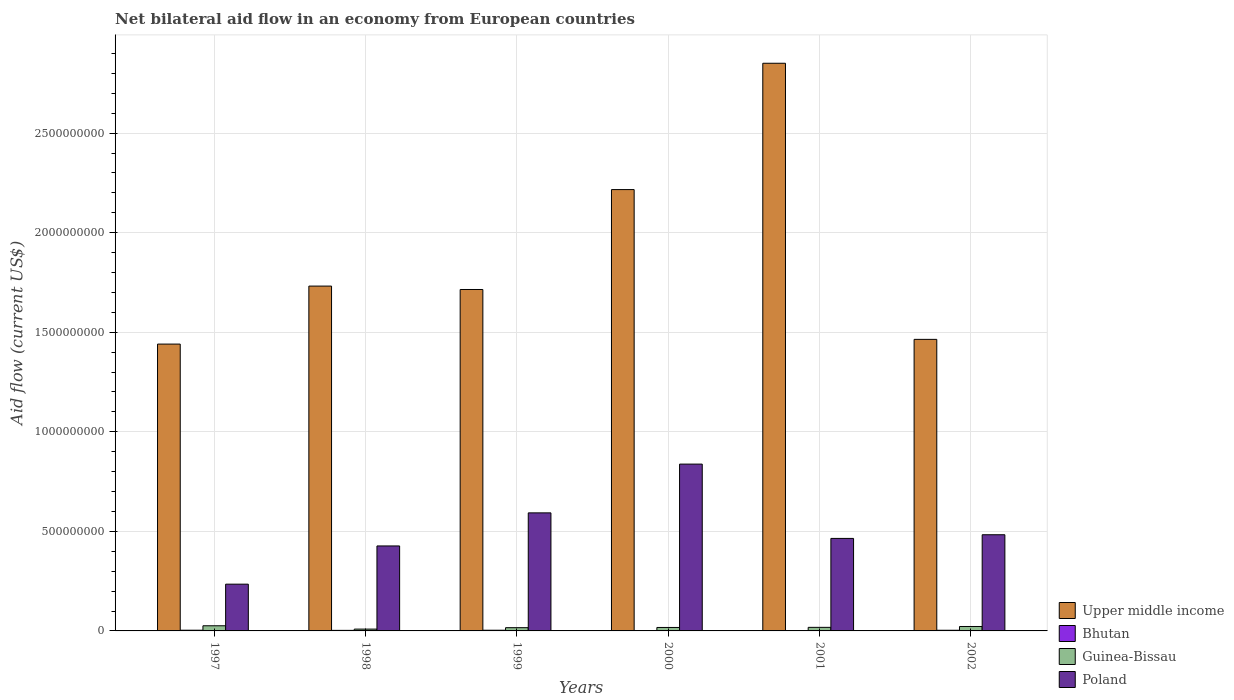How many different coloured bars are there?
Give a very brief answer. 4. How many groups of bars are there?
Offer a terse response. 6. Are the number of bars per tick equal to the number of legend labels?
Provide a succinct answer. Yes. How many bars are there on the 5th tick from the left?
Make the answer very short. 4. How many bars are there on the 1st tick from the right?
Make the answer very short. 4. What is the label of the 5th group of bars from the left?
Provide a succinct answer. 2001. In how many cases, is the number of bars for a given year not equal to the number of legend labels?
Offer a terse response. 0. What is the net bilateral aid flow in Bhutan in 1997?
Provide a succinct answer. 3.55e+06. Across all years, what is the maximum net bilateral aid flow in Upper middle income?
Make the answer very short. 2.85e+09. Across all years, what is the minimum net bilateral aid flow in Poland?
Give a very brief answer. 2.35e+08. What is the total net bilateral aid flow in Upper middle income in the graph?
Provide a succinct answer. 1.14e+1. What is the difference between the net bilateral aid flow in Poland in 1997 and that in 2000?
Your answer should be very brief. -6.03e+08. What is the difference between the net bilateral aid flow in Upper middle income in 2000 and the net bilateral aid flow in Bhutan in 1998?
Your answer should be compact. 2.21e+09. What is the average net bilateral aid flow in Bhutan per year?
Your answer should be compact. 2.61e+06. In the year 2001, what is the difference between the net bilateral aid flow in Bhutan and net bilateral aid flow in Poland?
Make the answer very short. -4.63e+08. What is the ratio of the net bilateral aid flow in Bhutan in 2000 to that in 2001?
Give a very brief answer. 0.57. Is the net bilateral aid flow in Guinea-Bissau in 1998 less than that in 2000?
Provide a succinct answer. Yes. Is the difference between the net bilateral aid flow in Bhutan in 2000 and 2002 greater than the difference between the net bilateral aid flow in Poland in 2000 and 2002?
Offer a terse response. No. What is the difference between the highest and the second highest net bilateral aid flow in Upper middle income?
Your response must be concise. 6.34e+08. What is the difference between the highest and the lowest net bilateral aid flow in Upper middle income?
Your answer should be compact. 1.41e+09. In how many years, is the net bilateral aid flow in Guinea-Bissau greater than the average net bilateral aid flow in Guinea-Bissau taken over all years?
Your response must be concise. 2. What does the 3rd bar from the left in 1999 represents?
Make the answer very short. Guinea-Bissau. What does the 4th bar from the right in 1998 represents?
Make the answer very short. Upper middle income. Are all the bars in the graph horizontal?
Keep it short and to the point. No. How are the legend labels stacked?
Make the answer very short. Vertical. What is the title of the graph?
Provide a short and direct response. Net bilateral aid flow in an economy from European countries. Does "Germany" appear as one of the legend labels in the graph?
Your response must be concise. No. What is the Aid flow (current US$) in Upper middle income in 1997?
Give a very brief answer. 1.44e+09. What is the Aid flow (current US$) of Bhutan in 1997?
Provide a succinct answer. 3.55e+06. What is the Aid flow (current US$) in Guinea-Bissau in 1997?
Your response must be concise. 2.58e+07. What is the Aid flow (current US$) of Poland in 1997?
Provide a succinct answer. 2.35e+08. What is the Aid flow (current US$) in Upper middle income in 1998?
Offer a very short reply. 1.73e+09. What is the Aid flow (current US$) in Bhutan in 1998?
Give a very brief answer. 2.79e+06. What is the Aid flow (current US$) in Guinea-Bissau in 1998?
Keep it short and to the point. 9.11e+06. What is the Aid flow (current US$) of Poland in 1998?
Make the answer very short. 4.27e+08. What is the Aid flow (current US$) in Upper middle income in 1999?
Offer a terse response. 1.71e+09. What is the Aid flow (current US$) in Bhutan in 1999?
Provide a succinct answer. 3.50e+06. What is the Aid flow (current US$) of Guinea-Bissau in 1999?
Offer a terse response. 1.62e+07. What is the Aid flow (current US$) in Poland in 1999?
Provide a succinct answer. 5.93e+08. What is the Aid flow (current US$) in Upper middle income in 2000?
Offer a terse response. 2.22e+09. What is the Aid flow (current US$) in Bhutan in 2000?
Your response must be concise. 9.00e+05. What is the Aid flow (current US$) of Guinea-Bissau in 2000?
Provide a short and direct response. 1.74e+07. What is the Aid flow (current US$) of Poland in 2000?
Provide a succinct answer. 8.38e+08. What is the Aid flow (current US$) in Upper middle income in 2001?
Offer a terse response. 2.85e+09. What is the Aid flow (current US$) in Bhutan in 2001?
Your answer should be compact. 1.59e+06. What is the Aid flow (current US$) of Guinea-Bissau in 2001?
Keep it short and to the point. 1.80e+07. What is the Aid flow (current US$) of Poland in 2001?
Keep it short and to the point. 4.65e+08. What is the Aid flow (current US$) in Upper middle income in 2002?
Ensure brevity in your answer.  1.46e+09. What is the Aid flow (current US$) in Bhutan in 2002?
Provide a succinct answer. 3.35e+06. What is the Aid flow (current US$) in Guinea-Bissau in 2002?
Offer a very short reply. 2.23e+07. What is the Aid flow (current US$) of Poland in 2002?
Your response must be concise. 4.83e+08. Across all years, what is the maximum Aid flow (current US$) in Upper middle income?
Ensure brevity in your answer.  2.85e+09. Across all years, what is the maximum Aid flow (current US$) of Bhutan?
Ensure brevity in your answer.  3.55e+06. Across all years, what is the maximum Aid flow (current US$) in Guinea-Bissau?
Make the answer very short. 2.58e+07. Across all years, what is the maximum Aid flow (current US$) in Poland?
Your answer should be very brief. 8.38e+08. Across all years, what is the minimum Aid flow (current US$) of Upper middle income?
Provide a succinct answer. 1.44e+09. Across all years, what is the minimum Aid flow (current US$) in Bhutan?
Offer a terse response. 9.00e+05. Across all years, what is the minimum Aid flow (current US$) in Guinea-Bissau?
Your response must be concise. 9.11e+06. Across all years, what is the minimum Aid flow (current US$) in Poland?
Your answer should be compact. 2.35e+08. What is the total Aid flow (current US$) of Upper middle income in the graph?
Offer a very short reply. 1.14e+1. What is the total Aid flow (current US$) in Bhutan in the graph?
Offer a very short reply. 1.57e+07. What is the total Aid flow (current US$) of Guinea-Bissau in the graph?
Offer a very short reply. 1.09e+08. What is the total Aid flow (current US$) of Poland in the graph?
Your answer should be compact. 3.04e+09. What is the difference between the Aid flow (current US$) in Upper middle income in 1997 and that in 1998?
Make the answer very short. -2.91e+08. What is the difference between the Aid flow (current US$) of Bhutan in 1997 and that in 1998?
Provide a succinct answer. 7.60e+05. What is the difference between the Aid flow (current US$) of Guinea-Bissau in 1997 and that in 1998?
Give a very brief answer. 1.67e+07. What is the difference between the Aid flow (current US$) in Poland in 1997 and that in 1998?
Your response must be concise. -1.92e+08. What is the difference between the Aid flow (current US$) of Upper middle income in 1997 and that in 1999?
Ensure brevity in your answer.  -2.74e+08. What is the difference between the Aid flow (current US$) in Guinea-Bissau in 1997 and that in 1999?
Your answer should be compact. 9.60e+06. What is the difference between the Aid flow (current US$) of Poland in 1997 and that in 1999?
Offer a very short reply. -3.58e+08. What is the difference between the Aid flow (current US$) of Upper middle income in 1997 and that in 2000?
Keep it short and to the point. -7.76e+08. What is the difference between the Aid flow (current US$) in Bhutan in 1997 and that in 2000?
Your response must be concise. 2.65e+06. What is the difference between the Aid flow (current US$) of Guinea-Bissau in 1997 and that in 2000?
Provide a succinct answer. 8.49e+06. What is the difference between the Aid flow (current US$) in Poland in 1997 and that in 2000?
Offer a terse response. -6.03e+08. What is the difference between the Aid flow (current US$) in Upper middle income in 1997 and that in 2001?
Ensure brevity in your answer.  -1.41e+09. What is the difference between the Aid flow (current US$) of Bhutan in 1997 and that in 2001?
Your answer should be very brief. 1.96e+06. What is the difference between the Aid flow (current US$) of Guinea-Bissau in 1997 and that in 2001?
Keep it short and to the point. 7.90e+06. What is the difference between the Aid flow (current US$) of Poland in 1997 and that in 2001?
Offer a very short reply. -2.30e+08. What is the difference between the Aid flow (current US$) in Upper middle income in 1997 and that in 2002?
Your answer should be very brief. -2.37e+07. What is the difference between the Aid flow (current US$) of Guinea-Bissau in 1997 and that in 2002?
Keep it short and to the point. 3.58e+06. What is the difference between the Aid flow (current US$) of Poland in 1997 and that in 2002?
Your answer should be compact. -2.48e+08. What is the difference between the Aid flow (current US$) in Upper middle income in 1998 and that in 1999?
Your response must be concise. 1.71e+07. What is the difference between the Aid flow (current US$) in Bhutan in 1998 and that in 1999?
Your response must be concise. -7.10e+05. What is the difference between the Aid flow (current US$) of Guinea-Bissau in 1998 and that in 1999?
Your answer should be compact. -7.14e+06. What is the difference between the Aid flow (current US$) of Poland in 1998 and that in 1999?
Your response must be concise. -1.66e+08. What is the difference between the Aid flow (current US$) in Upper middle income in 1998 and that in 2000?
Offer a very short reply. -4.85e+08. What is the difference between the Aid flow (current US$) of Bhutan in 1998 and that in 2000?
Your answer should be compact. 1.89e+06. What is the difference between the Aid flow (current US$) in Guinea-Bissau in 1998 and that in 2000?
Give a very brief answer. -8.25e+06. What is the difference between the Aid flow (current US$) of Poland in 1998 and that in 2000?
Your answer should be very brief. -4.11e+08. What is the difference between the Aid flow (current US$) of Upper middle income in 1998 and that in 2001?
Provide a short and direct response. -1.12e+09. What is the difference between the Aid flow (current US$) of Bhutan in 1998 and that in 2001?
Your answer should be very brief. 1.20e+06. What is the difference between the Aid flow (current US$) in Guinea-Bissau in 1998 and that in 2001?
Your answer should be very brief. -8.84e+06. What is the difference between the Aid flow (current US$) in Poland in 1998 and that in 2001?
Your answer should be compact. -3.78e+07. What is the difference between the Aid flow (current US$) of Upper middle income in 1998 and that in 2002?
Keep it short and to the point. 2.68e+08. What is the difference between the Aid flow (current US$) in Bhutan in 1998 and that in 2002?
Your response must be concise. -5.60e+05. What is the difference between the Aid flow (current US$) of Guinea-Bissau in 1998 and that in 2002?
Offer a very short reply. -1.32e+07. What is the difference between the Aid flow (current US$) in Poland in 1998 and that in 2002?
Your answer should be very brief. -5.62e+07. What is the difference between the Aid flow (current US$) in Upper middle income in 1999 and that in 2000?
Keep it short and to the point. -5.02e+08. What is the difference between the Aid flow (current US$) in Bhutan in 1999 and that in 2000?
Provide a succinct answer. 2.60e+06. What is the difference between the Aid flow (current US$) in Guinea-Bissau in 1999 and that in 2000?
Provide a succinct answer. -1.11e+06. What is the difference between the Aid flow (current US$) of Poland in 1999 and that in 2000?
Offer a terse response. -2.45e+08. What is the difference between the Aid flow (current US$) of Upper middle income in 1999 and that in 2001?
Offer a terse response. -1.14e+09. What is the difference between the Aid flow (current US$) of Bhutan in 1999 and that in 2001?
Offer a terse response. 1.91e+06. What is the difference between the Aid flow (current US$) in Guinea-Bissau in 1999 and that in 2001?
Give a very brief answer. -1.70e+06. What is the difference between the Aid flow (current US$) in Poland in 1999 and that in 2001?
Make the answer very short. 1.28e+08. What is the difference between the Aid flow (current US$) of Upper middle income in 1999 and that in 2002?
Offer a very short reply. 2.51e+08. What is the difference between the Aid flow (current US$) in Guinea-Bissau in 1999 and that in 2002?
Give a very brief answer. -6.02e+06. What is the difference between the Aid flow (current US$) in Poland in 1999 and that in 2002?
Make the answer very short. 1.10e+08. What is the difference between the Aid flow (current US$) in Upper middle income in 2000 and that in 2001?
Your response must be concise. -6.34e+08. What is the difference between the Aid flow (current US$) of Bhutan in 2000 and that in 2001?
Your answer should be very brief. -6.90e+05. What is the difference between the Aid flow (current US$) in Guinea-Bissau in 2000 and that in 2001?
Provide a succinct answer. -5.90e+05. What is the difference between the Aid flow (current US$) of Poland in 2000 and that in 2001?
Keep it short and to the point. 3.73e+08. What is the difference between the Aid flow (current US$) of Upper middle income in 2000 and that in 2002?
Make the answer very short. 7.52e+08. What is the difference between the Aid flow (current US$) of Bhutan in 2000 and that in 2002?
Offer a terse response. -2.45e+06. What is the difference between the Aid flow (current US$) in Guinea-Bissau in 2000 and that in 2002?
Give a very brief answer. -4.91e+06. What is the difference between the Aid flow (current US$) in Poland in 2000 and that in 2002?
Your answer should be compact. 3.55e+08. What is the difference between the Aid flow (current US$) in Upper middle income in 2001 and that in 2002?
Make the answer very short. 1.39e+09. What is the difference between the Aid flow (current US$) in Bhutan in 2001 and that in 2002?
Provide a short and direct response. -1.76e+06. What is the difference between the Aid flow (current US$) of Guinea-Bissau in 2001 and that in 2002?
Make the answer very short. -4.32e+06. What is the difference between the Aid flow (current US$) in Poland in 2001 and that in 2002?
Provide a succinct answer. -1.84e+07. What is the difference between the Aid flow (current US$) in Upper middle income in 1997 and the Aid flow (current US$) in Bhutan in 1998?
Provide a short and direct response. 1.44e+09. What is the difference between the Aid flow (current US$) in Upper middle income in 1997 and the Aid flow (current US$) in Guinea-Bissau in 1998?
Offer a terse response. 1.43e+09. What is the difference between the Aid flow (current US$) of Upper middle income in 1997 and the Aid flow (current US$) of Poland in 1998?
Provide a short and direct response. 1.01e+09. What is the difference between the Aid flow (current US$) of Bhutan in 1997 and the Aid flow (current US$) of Guinea-Bissau in 1998?
Offer a very short reply. -5.56e+06. What is the difference between the Aid flow (current US$) in Bhutan in 1997 and the Aid flow (current US$) in Poland in 1998?
Offer a terse response. -4.23e+08. What is the difference between the Aid flow (current US$) in Guinea-Bissau in 1997 and the Aid flow (current US$) in Poland in 1998?
Ensure brevity in your answer.  -4.01e+08. What is the difference between the Aid flow (current US$) in Upper middle income in 1997 and the Aid flow (current US$) in Bhutan in 1999?
Your response must be concise. 1.44e+09. What is the difference between the Aid flow (current US$) of Upper middle income in 1997 and the Aid flow (current US$) of Guinea-Bissau in 1999?
Make the answer very short. 1.42e+09. What is the difference between the Aid flow (current US$) in Upper middle income in 1997 and the Aid flow (current US$) in Poland in 1999?
Your response must be concise. 8.48e+08. What is the difference between the Aid flow (current US$) in Bhutan in 1997 and the Aid flow (current US$) in Guinea-Bissau in 1999?
Provide a short and direct response. -1.27e+07. What is the difference between the Aid flow (current US$) of Bhutan in 1997 and the Aid flow (current US$) of Poland in 1999?
Give a very brief answer. -5.89e+08. What is the difference between the Aid flow (current US$) in Guinea-Bissau in 1997 and the Aid flow (current US$) in Poland in 1999?
Give a very brief answer. -5.67e+08. What is the difference between the Aid flow (current US$) of Upper middle income in 1997 and the Aid flow (current US$) of Bhutan in 2000?
Offer a terse response. 1.44e+09. What is the difference between the Aid flow (current US$) in Upper middle income in 1997 and the Aid flow (current US$) in Guinea-Bissau in 2000?
Your response must be concise. 1.42e+09. What is the difference between the Aid flow (current US$) of Upper middle income in 1997 and the Aid flow (current US$) of Poland in 2000?
Keep it short and to the point. 6.03e+08. What is the difference between the Aid flow (current US$) of Bhutan in 1997 and the Aid flow (current US$) of Guinea-Bissau in 2000?
Ensure brevity in your answer.  -1.38e+07. What is the difference between the Aid flow (current US$) of Bhutan in 1997 and the Aid flow (current US$) of Poland in 2000?
Make the answer very short. -8.34e+08. What is the difference between the Aid flow (current US$) of Guinea-Bissau in 1997 and the Aid flow (current US$) of Poland in 2000?
Provide a short and direct response. -8.12e+08. What is the difference between the Aid flow (current US$) of Upper middle income in 1997 and the Aid flow (current US$) of Bhutan in 2001?
Offer a terse response. 1.44e+09. What is the difference between the Aid flow (current US$) of Upper middle income in 1997 and the Aid flow (current US$) of Guinea-Bissau in 2001?
Your answer should be very brief. 1.42e+09. What is the difference between the Aid flow (current US$) of Upper middle income in 1997 and the Aid flow (current US$) of Poland in 2001?
Your answer should be very brief. 9.76e+08. What is the difference between the Aid flow (current US$) in Bhutan in 1997 and the Aid flow (current US$) in Guinea-Bissau in 2001?
Your answer should be very brief. -1.44e+07. What is the difference between the Aid flow (current US$) of Bhutan in 1997 and the Aid flow (current US$) of Poland in 2001?
Offer a terse response. -4.61e+08. What is the difference between the Aid flow (current US$) in Guinea-Bissau in 1997 and the Aid flow (current US$) in Poland in 2001?
Keep it short and to the point. -4.39e+08. What is the difference between the Aid flow (current US$) of Upper middle income in 1997 and the Aid flow (current US$) of Bhutan in 2002?
Provide a succinct answer. 1.44e+09. What is the difference between the Aid flow (current US$) of Upper middle income in 1997 and the Aid flow (current US$) of Guinea-Bissau in 2002?
Offer a terse response. 1.42e+09. What is the difference between the Aid flow (current US$) in Upper middle income in 1997 and the Aid flow (current US$) in Poland in 2002?
Make the answer very short. 9.58e+08. What is the difference between the Aid flow (current US$) of Bhutan in 1997 and the Aid flow (current US$) of Guinea-Bissau in 2002?
Make the answer very short. -1.87e+07. What is the difference between the Aid flow (current US$) of Bhutan in 1997 and the Aid flow (current US$) of Poland in 2002?
Keep it short and to the point. -4.79e+08. What is the difference between the Aid flow (current US$) of Guinea-Bissau in 1997 and the Aid flow (current US$) of Poland in 2002?
Your answer should be very brief. -4.57e+08. What is the difference between the Aid flow (current US$) in Upper middle income in 1998 and the Aid flow (current US$) in Bhutan in 1999?
Give a very brief answer. 1.73e+09. What is the difference between the Aid flow (current US$) of Upper middle income in 1998 and the Aid flow (current US$) of Guinea-Bissau in 1999?
Give a very brief answer. 1.72e+09. What is the difference between the Aid flow (current US$) of Upper middle income in 1998 and the Aid flow (current US$) of Poland in 1999?
Provide a succinct answer. 1.14e+09. What is the difference between the Aid flow (current US$) in Bhutan in 1998 and the Aid flow (current US$) in Guinea-Bissau in 1999?
Provide a short and direct response. -1.35e+07. What is the difference between the Aid flow (current US$) in Bhutan in 1998 and the Aid flow (current US$) in Poland in 1999?
Your answer should be very brief. -5.90e+08. What is the difference between the Aid flow (current US$) in Guinea-Bissau in 1998 and the Aid flow (current US$) in Poland in 1999?
Provide a short and direct response. -5.84e+08. What is the difference between the Aid flow (current US$) in Upper middle income in 1998 and the Aid flow (current US$) in Bhutan in 2000?
Ensure brevity in your answer.  1.73e+09. What is the difference between the Aid flow (current US$) of Upper middle income in 1998 and the Aid flow (current US$) of Guinea-Bissau in 2000?
Make the answer very short. 1.71e+09. What is the difference between the Aid flow (current US$) of Upper middle income in 1998 and the Aid flow (current US$) of Poland in 2000?
Give a very brief answer. 8.94e+08. What is the difference between the Aid flow (current US$) of Bhutan in 1998 and the Aid flow (current US$) of Guinea-Bissau in 2000?
Ensure brevity in your answer.  -1.46e+07. What is the difference between the Aid flow (current US$) of Bhutan in 1998 and the Aid flow (current US$) of Poland in 2000?
Offer a terse response. -8.35e+08. What is the difference between the Aid flow (current US$) in Guinea-Bissau in 1998 and the Aid flow (current US$) in Poland in 2000?
Make the answer very short. -8.29e+08. What is the difference between the Aid flow (current US$) in Upper middle income in 1998 and the Aid flow (current US$) in Bhutan in 2001?
Provide a short and direct response. 1.73e+09. What is the difference between the Aid flow (current US$) of Upper middle income in 1998 and the Aid flow (current US$) of Guinea-Bissau in 2001?
Provide a short and direct response. 1.71e+09. What is the difference between the Aid flow (current US$) of Upper middle income in 1998 and the Aid flow (current US$) of Poland in 2001?
Offer a terse response. 1.27e+09. What is the difference between the Aid flow (current US$) in Bhutan in 1998 and the Aid flow (current US$) in Guinea-Bissau in 2001?
Provide a succinct answer. -1.52e+07. What is the difference between the Aid flow (current US$) of Bhutan in 1998 and the Aid flow (current US$) of Poland in 2001?
Give a very brief answer. -4.62e+08. What is the difference between the Aid flow (current US$) of Guinea-Bissau in 1998 and the Aid flow (current US$) of Poland in 2001?
Keep it short and to the point. -4.56e+08. What is the difference between the Aid flow (current US$) of Upper middle income in 1998 and the Aid flow (current US$) of Bhutan in 2002?
Offer a very short reply. 1.73e+09. What is the difference between the Aid flow (current US$) in Upper middle income in 1998 and the Aid flow (current US$) in Guinea-Bissau in 2002?
Your response must be concise. 1.71e+09. What is the difference between the Aid flow (current US$) in Upper middle income in 1998 and the Aid flow (current US$) in Poland in 2002?
Your response must be concise. 1.25e+09. What is the difference between the Aid flow (current US$) of Bhutan in 1998 and the Aid flow (current US$) of Guinea-Bissau in 2002?
Your answer should be compact. -1.95e+07. What is the difference between the Aid flow (current US$) in Bhutan in 1998 and the Aid flow (current US$) in Poland in 2002?
Offer a very short reply. -4.80e+08. What is the difference between the Aid flow (current US$) of Guinea-Bissau in 1998 and the Aid flow (current US$) of Poland in 2002?
Give a very brief answer. -4.74e+08. What is the difference between the Aid flow (current US$) in Upper middle income in 1999 and the Aid flow (current US$) in Bhutan in 2000?
Make the answer very short. 1.71e+09. What is the difference between the Aid flow (current US$) in Upper middle income in 1999 and the Aid flow (current US$) in Guinea-Bissau in 2000?
Your answer should be compact. 1.70e+09. What is the difference between the Aid flow (current US$) of Upper middle income in 1999 and the Aid flow (current US$) of Poland in 2000?
Provide a succinct answer. 8.77e+08. What is the difference between the Aid flow (current US$) in Bhutan in 1999 and the Aid flow (current US$) in Guinea-Bissau in 2000?
Give a very brief answer. -1.39e+07. What is the difference between the Aid flow (current US$) of Bhutan in 1999 and the Aid flow (current US$) of Poland in 2000?
Give a very brief answer. -8.34e+08. What is the difference between the Aid flow (current US$) in Guinea-Bissau in 1999 and the Aid flow (current US$) in Poland in 2000?
Offer a very short reply. -8.22e+08. What is the difference between the Aid flow (current US$) of Upper middle income in 1999 and the Aid flow (current US$) of Bhutan in 2001?
Keep it short and to the point. 1.71e+09. What is the difference between the Aid flow (current US$) in Upper middle income in 1999 and the Aid flow (current US$) in Guinea-Bissau in 2001?
Provide a short and direct response. 1.70e+09. What is the difference between the Aid flow (current US$) of Upper middle income in 1999 and the Aid flow (current US$) of Poland in 2001?
Provide a succinct answer. 1.25e+09. What is the difference between the Aid flow (current US$) of Bhutan in 1999 and the Aid flow (current US$) of Guinea-Bissau in 2001?
Provide a succinct answer. -1.44e+07. What is the difference between the Aid flow (current US$) of Bhutan in 1999 and the Aid flow (current US$) of Poland in 2001?
Your answer should be very brief. -4.61e+08. What is the difference between the Aid flow (current US$) in Guinea-Bissau in 1999 and the Aid flow (current US$) in Poland in 2001?
Your answer should be compact. -4.48e+08. What is the difference between the Aid flow (current US$) in Upper middle income in 1999 and the Aid flow (current US$) in Bhutan in 2002?
Offer a terse response. 1.71e+09. What is the difference between the Aid flow (current US$) of Upper middle income in 1999 and the Aid flow (current US$) of Guinea-Bissau in 2002?
Provide a short and direct response. 1.69e+09. What is the difference between the Aid flow (current US$) in Upper middle income in 1999 and the Aid flow (current US$) in Poland in 2002?
Provide a short and direct response. 1.23e+09. What is the difference between the Aid flow (current US$) of Bhutan in 1999 and the Aid flow (current US$) of Guinea-Bissau in 2002?
Offer a terse response. -1.88e+07. What is the difference between the Aid flow (current US$) in Bhutan in 1999 and the Aid flow (current US$) in Poland in 2002?
Ensure brevity in your answer.  -4.80e+08. What is the difference between the Aid flow (current US$) in Guinea-Bissau in 1999 and the Aid flow (current US$) in Poland in 2002?
Your answer should be very brief. -4.67e+08. What is the difference between the Aid flow (current US$) of Upper middle income in 2000 and the Aid flow (current US$) of Bhutan in 2001?
Keep it short and to the point. 2.22e+09. What is the difference between the Aid flow (current US$) in Upper middle income in 2000 and the Aid flow (current US$) in Guinea-Bissau in 2001?
Your answer should be compact. 2.20e+09. What is the difference between the Aid flow (current US$) in Upper middle income in 2000 and the Aid flow (current US$) in Poland in 2001?
Offer a very short reply. 1.75e+09. What is the difference between the Aid flow (current US$) of Bhutan in 2000 and the Aid flow (current US$) of Guinea-Bissau in 2001?
Keep it short and to the point. -1.70e+07. What is the difference between the Aid flow (current US$) in Bhutan in 2000 and the Aid flow (current US$) in Poland in 2001?
Offer a very short reply. -4.64e+08. What is the difference between the Aid flow (current US$) in Guinea-Bissau in 2000 and the Aid flow (current US$) in Poland in 2001?
Your answer should be very brief. -4.47e+08. What is the difference between the Aid flow (current US$) of Upper middle income in 2000 and the Aid flow (current US$) of Bhutan in 2002?
Make the answer very short. 2.21e+09. What is the difference between the Aid flow (current US$) in Upper middle income in 2000 and the Aid flow (current US$) in Guinea-Bissau in 2002?
Your response must be concise. 2.19e+09. What is the difference between the Aid flow (current US$) of Upper middle income in 2000 and the Aid flow (current US$) of Poland in 2002?
Provide a succinct answer. 1.73e+09. What is the difference between the Aid flow (current US$) in Bhutan in 2000 and the Aid flow (current US$) in Guinea-Bissau in 2002?
Provide a short and direct response. -2.14e+07. What is the difference between the Aid flow (current US$) in Bhutan in 2000 and the Aid flow (current US$) in Poland in 2002?
Provide a succinct answer. -4.82e+08. What is the difference between the Aid flow (current US$) of Guinea-Bissau in 2000 and the Aid flow (current US$) of Poland in 2002?
Offer a very short reply. -4.66e+08. What is the difference between the Aid flow (current US$) in Upper middle income in 2001 and the Aid flow (current US$) in Bhutan in 2002?
Provide a succinct answer. 2.85e+09. What is the difference between the Aid flow (current US$) of Upper middle income in 2001 and the Aid flow (current US$) of Guinea-Bissau in 2002?
Ensure brevity in your answer.  2.83e+09. What is the difference between the Aid flow (current US$) of Upper middle income in 2001 and the Aid flow (current US$) of Poland in 2002?
Provide a succinct answer. 2.37e+09. What is the difference between the Aid flow (current US$) of Bhutan in 2001 and the Aid flow (current US$) of Guinea-Bissau in 2002?
Make the answer very short. -2.07e+07. What is the difference between the Aid flow (current US$) of Bhutan in 2001 and the Aid flow (current US$) of Poland in 2002?
Your response must be concise. -4.81e+08. What is the difference between the Aid flow (current US$) of Guinea-Bissau in 2001 and the Aid flow (current US$) of Poland in 2002?
Keep it short and to the point. -4.65e+08. What is the average Aid flow (current US$) in Upper middle income per year?
Keep it short and to the point. 1.90e+09. What is the average Aid flow (current US$) in Bhutan per year?
Your answer should be very brief. 2.61e+06. What is the average Aid flow (current US$) of Guinea-Bissau per year?
Give a very brief answer. 1.81e+07. What is the average Aid flow (current US$) of Poland per year?
Keep it short and to the point. 5.07e+08. In the year 1997, what is the difference between the Aid flow (current US$) in Upper middle income and Aid flow (current US$) in Bhutan?
Your response must be concise. 1.44e+09. In the year 1997, what is the difference between the Aid flow (current US$) in Upper middle income and Aid flow (current US$) in Guinea-Bissau?
Ensure brevity in your answer.  1.41e+09. In the year 1997, what is the difference between the Aid flow (current US$) in Upper middle income and Aid flow (current US$) in Poland?
Make the answer very short. 1.21e+09. In the year 1997, what is the difference between the Aid flow (current US$) of Bhutan and Aid flow (current US$) of Guinea-Bissau?
Keep it short and to the point. -2.23e+07. In the year 1997, what is the difference between the Aid flow (current US$) in Bhutan and Aid flow (current US$) in Poland?
Your answer should be very brief. -2.31e+08. In the year 1997, what is the difference between the Aid flow (current US$) of Guinea-Bissau and Aid flow (current US$) of Poland?
Offer a very short reply. -2.09e+08. In the year 1998, what is the difference between the Aid flow (current US$) of Upper middle income and Aid flow (current US$) of Bhutan?
Keep it short and to the point. 1.73e+09. In the year 1998, what is the difference between the Aid flow (current US$) of Upper middle income and Aid flow (current US$) of Guinea-Bissau?
Keep it short and to the point. 1.72e+09. In the year 1998, what is the difference between the Aid flow (current US$) in Upper middle income and Aid flow (current US$) in Poland?
Ensure brevity in your answer.  1.31e+09. In the year 1998, what is the difference between the Aid flow (current US$) of Bhutan and Aid flow (current US$) of Guinea-Bissau?
Offer a very short reply. -6.32e+06. In the year 1998, what is the difference between the Aid flow (current US$) of Bhutan and Aid flow (current US$) of Poland?
Offer a terse response. -4.24e+08. In the year 1998, what is the difference between the Aid flow (current US$) in Guinea-Bissau and Aid flow (current US$) in Poland?
Offer a very short reply. -4.18e+08. In the year 1999, what is the difference between the Aid flow (current US$) in Upper middle income and Aid flow (current US$) in Bhutan?
Ensure brevity in your answer.  1.71e+09. In the year 1999, what is the difference between the Aid flow (current US$) of Upper middle income and Aid flow (current US$) of Guinea-Bissau?
Give a very brief answer. 1.70e+09. In the year 1999, what is the difference between the Aid flow (current US$) of Upper middle income and Aid flow (current US$) of Poland?
Offer a very short reply. 1.12e+09. In the year 1999, what is the difference between the Aid flow (current US$) of Bhutan and Aid flow (current US$) of Guinea-Bissau?
Your answer should be very brief. -1.28e+07. In the year 1999, what is the difference between the Aid flow (current US$) in Bhutan and Aid flow (current US$) in Poland?
Your response must be concise. -5.89e+08. In the year 1999, what is the difference between the Aid flow (current US$) in Guinea-Bissau and Aid flow (current US$) in Poland?
Make the answer very short. -5.77e+08. In the year 2000, what is the difference between the Aid flow (current US$) of Upper middle income and Aid flow (current US$) of Bhutan?
Keep it short and to the point. 2.22e+09. In the year 2000, what is the difference between the Aid flow (current US$) of Upper middle income and Aid flow (current US$) of Guinea-Bissau?
Make the answer very short. 2.20e+09. In the year 2000, what is the difference between the Aid flow (current US$) in Upper middle income and Aid flow (current US$) in Poland?
Provide a succinct answer. 1.38e+09. In the year 2000, what is the difference between the Aid flow (current US$) in Bhutan and Aid flow (current US$) in Guinea-Bissau?
Your answer should be compact. -1.65e+07. In the year 2000, what is the difference between the Aid flow (current US$) of Bhutan and Aid flow (current US$) of Poland?
Ensure brevity in your answer.  -8.37e+08. In the year 2000, what is the difference between the Aid flow (current US$) of Guinea-Bissau and Aid flow (current US$) of Poland?
Provide a succinct answer. -8.20e+08. In the year 2001, what is the difference between the Aid flow (current US$) of Upper middle income and Aid flow (current US$) of Bhutan?
Offer a very short reply. 2.85e+09. In the year 2001, what is the difference between the Aid flow (current US$) of Upper middle income and Aid flow (current US$) of Guinea-Bissau?
Provide a short and direct response. 2.83e+09. In the year 2001, what is the difference between the Aid flow (current US$) in Upper middle income and Aid flow (current US$) in Poland?
Ensure brevity in your answer.  2.39e+09. In the year 2001, what is the difference between the Aid flow (current US$) in Bhutan and Aid flow (current US$) in Guinea-Bissau?
Ensure brevity in your answer.  -1.64e+07. In the year 2001, what is the difference between the Aid flow (current US$) of Bhutan and Aid flow (current US$) of Poland?
Your answer should be very brief. -4.63e+08. In the year 2001, what is the difference between the Aid flow (current US$) in Guinea-Bissau and Aid flow (current US$) in Poland?
Your response must be concise. -4.47e+08. In the year 2002, what is the difference between the Aid flow (current US$) of Upper middle income and Aid flow (current US$) of Bhutan?
Offer a very short reply. 1.46e+09. In the year 2002, what is the difference between the Aid flow (current US$) of Upper middle income and Aid flow (current US$) of Guinea-Bissau?
Provide a short and direct response. 1.44e+09. In the year 2002, what is the difference between the Aid flow (current US$) of Upper middle income and Aid flow (current US$) of Poland?
Provide a short and direct response. 9.81e+08. In the year 2002, what is the difference between the Aid flow (current US$) of Bhutan and Aid flow (current US$) of Guinea-Bissau?
Keep it short and to the point. -1.89e+07. In the year 2002, what is the difference between the Aid flow (current US$) in Bhutan and Aid flow (current US$) in Poland?
Provide a succinct answer. -4.80e+08. In the year 2002, what is the difference between the Aid flow (current US$) in Guinea-Bissau and Aid flow (current US$) in Poland?
Provide a short and direct response. -4.61e+08. What is the ratio of the Aid flow (current US$) in Upper middle income in 1997 to that in 1998?
Make the answer very short. 0.83. What is the ratio of the Aid flow (current US$) in Bhutan in 1997 to that in 1998?
Your response must be concise. 1.27. What is the ratio of the Aid flow (current US$) of Guinea-Bissau in 1997 to that in 1998?
Provide a short and direct response. 2.84. What is the ratio of the Aid flow (current US$) of Poland in 1997 to that in 1998?
Your answer should be very brief. 0.55. What is the ratio of the Aid flow (current US$) in Upper middle income in 1997 to that in 1999?
Provide a short and direct response. 0.84. What is the ratio of the Aid flow (current US$) in Bhutan in 1997 to that in 1999?
Your answer should be very brief. 1.01. What is the ratio of the Aid flow (current US$) in Guinea-Bissau in 1997 to that in 1999?
Offer a terse response. 1.59. What is the ratio of the Aid flow (current US$) in Poland in 1997 to that in 1999?
Give a very brief answer. 0.4. What is the ratio of the Aid flow (current US$) of Upper middle income in 1997 to that in 2000?
Make the answer very short. 0.65. What is the ratio of the Aid flow (current US$) in Bhutan in 1997 to that in 2000?
Offer a very short reply. 3.94. What is the ratio of the Aid flow (current US$) in Guinea-Bissau in 1997 to that in 2000?
Provide a succinct answer. 1.49. What is the ratio of the Aid flow (current US$) of Poland in 1997 to that in 2000?
Your response must be concise. 0.28. What is the ratio of the Aid flow (current US$) of Upper middle income in 1997 to that in 2001?
Your response must be concise. 0.51. What is the ratio of the Aid flow (current US$) of Bhutan in 1997 to that in 2001?
Keep it short and to the point. 2.23. What is the ratio of the Aid flow (current US$) of Guinea-Bissau in 1997 to that in 2001?
Provide a succinct answer. 1.44. What is the ratio of the Aid flow (current US$) of Poland in 1997 to that in 2001?
Offer a very short reply. 0.51. What is the ratio of the Aid flow (current US$) of Upper middle income in 1997 to that in 2002?
Provide a short and direct response. 0.98. What is the ratio of the Aid flow (current US$) in Bhutan in 1997 to that in 2002?
Your answer should be compact. 1.06. What is the ratio of the Aid flow (current US$) of Guinea-Bissau in 1997 to that in 2002?
Give a very brief answer. 1.16. What is the ratio of the Aid flow (current US$) in Poland in 1997 to that in 2002?
Make the answer very short. 0.49. What is the ratio of the Aid flow (current US$) in Upper middle income in 1998 to that in 1999?
Ensure brevity in your answer.  1.01. What is the ratio of the Aid flow (current US$) in Bhutan in 1998 to that in 1999?
Your answer should be compact. 0.8. What is the ratio of the Aid flow (current US$) in Guinea-Bissau in 1998 to that in 1999?
Your response must be concise. 0.56. What is the ratio of the Aid flow (current US$) in Poland in 1998 to that in 1999?
Give a very brief answer. 0.72. What is the ratio of the Aid flow (current US$) in Upper middle income in 1998 to that in 2000?
Offer a very short reply. 0.78. What is the ratio of the Aid flow (current US$) of Guinea-Bissau in 1998 to that in 2000?
Ensure brevity in your answer.  0.52. What is the ratio of the Aid flow (current US$) of Poland in 1998 to that in 2000?
Provide a short and direct response. 0.51. What is the ratio of the Aid flow (current US$) in Upper middle income in 1998 to that in 2001?
Provide a succinct answer. 0.61. What is the ratio of the Aid flow (current US$) of Bhutan in 1998 to that in 2001?
Provide a succinct answer. 1.75. What is the ratio of the Aid flow (current US$) of Guinea-Bissau in 1998 to that in 2001?
Ensure brevity in your answer.  0.51. What is the ratio of the Aid flow (current US$) in Poland in 1998 to that in 2001?
Give a very brief answer. 0.92. What is the ratio of the Aid flow (current US$) of Upper middle income in 1998 to that in 2002?
Your response must be concise. 1.18. What is the ratio of the Aid flow (current US$) in Bhutan in 1998 to that in 2002?
Your answer should be very brief. 0.83. What is the ratio of the Aid flow (current US$) of Guinea-Bissau in 1998 to that in 2002?
Offer a terse response. 0.41. What is the ratio of the Aid flow (current US$) of Poland in 1998 to that in 2002?
Ensure brevity in your answer.  0.88. What is the ratio of the Aid flow (current US$) of Upper middle income in 1999 to that in 2000?
Provide a short and direct response. 0.77. What is the ratio of the Aid flow (current US$) in Bhutan in 1999 to that in 2000?
Offer a very short reply. 3.89. What is the ratio of the Aid flow (current US$) in Guinea-Bissau in 1999 to that in 2000?
Keep it short and to the point. 0.94. What is the ratio of the Aid flow (current US$) of Poland in 1999 to that in 2000?
Your answer should be very brief. 0.71. What is the ratio of the Aid flow (current US$) of Upper middle income in 1999 to that in 2001?
Offer a terse response. 0.6. What is the ratio of the Aid flow (current US$) in Bhutan in 1999 to that in 2001?
Provide a succinct answer. 2.2. What is the ratio of the Aid flow (current US$) of Guinea-Bissau in 1999 to that in 2001?
Your answer should be compact. 0.91. What is the ratio of the Aid flow (current US$) of Poland in 1999 to that in 2001?
Offer a very short reply. 1.28. What is the ratio of the Aid flow (current US$) of Upper middle income in 1999 to that in 2002?
Your answer should be very brief. 1.17. What is the ratio of the Aid flow (current US$) in Bhutan in 1999 to that in 2002?
Give a very brief answer. 1.04. What is the ratio of the Aid flow (current US$) in Guinea-Bissau in 1999 to that in 2002?
Your answer should be compact. 0.73. What is the ratio of the Aid flow (current US$) in Poland in 1999 to that in 2002?
Your response must be concise. 1.23. What is the ratio of the Aid flow (current US$) of Upper middle income in 2000 to that in 2001?
Offer a very short reply. 0.78. What is the ratio of the Aid flow (current US$) of Bhutan in 2000 to that in 2001?
Keep it short and to the point. 0.57. What is the ratio of the Aid flow (current US$) of Guinea-Bissau in 2000 to that in 2001?
Ensure brevity in your answer.  0.97. What is the ratio of the Aid flow (current US$) in Poland in 2000 to that in 2001?
Your answer should be compact. 1.8. What is the ratio of the Aid flow (current US$) in Upper middle income in 2000 to that in 2002?
Offer a very short reply. 1.51. What is the ratio of the Aid flow (current US$) of Bhutan in 2000 to that in 2002?
Your answer should be compact. 0.27. What is the ratio of the Aid flow (current US$) in Guinea-Bissau in 2000 to that in 2002?
Your response must be concise. 0.78. What is the ratio of the Aid flow (current US$) of Poland in 2000 to that in 2002?
Make the answer very short. 1.73. What is the ratio of the Aid flow (current US$) of Upper middle income in 2001 to that in 2002?
Your answer should be very brief. 1.95. What is the ratio of the Aid flow (current US$) of Bhutan in 2001 to that in 2002?
Your answer should be compact. 0.47. What is the ratio of the Aid flow (current US$) of Guinea-Bissau in 2001 to that in 2002?
Ensure brevity in your answer.  0.81. What is the ratio of the Aid flow (current US$) in Poland in 2001 to that in 2002?
Offer a terse response. 0.96. What is the difference between the highest and the second highest Aid flow (current US$) in Upper middle income?
Offer a very short reply. 6.34e+08. What is the difference between the highest and the second highest Aid flow (current US$) of Guinea-Bissau?
Your answer should be very brief. 3.58e+06. What is the difference between the highest and the second highest Aid flow (current US$) in Poland?
Offer a very short reply. 2.45e+08. What is the difference between the highest and the lowest Aid flow (current US$) in Upper middle income?
Provide a succinct answer. 1.41e+09. What is the difference between the highest and the lowest Aid flow (current US$) of Bhutan?
Offer a terse response. 2.65e+06. What is the difference between the highest and the lowest Aid flow (current US$) in Guinea-Bissau?
Your answer should be compact. 1.67e+07. What is the difference between the highest and the lowest Aid flow (current US$) in Poland?
Offer a very short reply. 6.03e+08. 